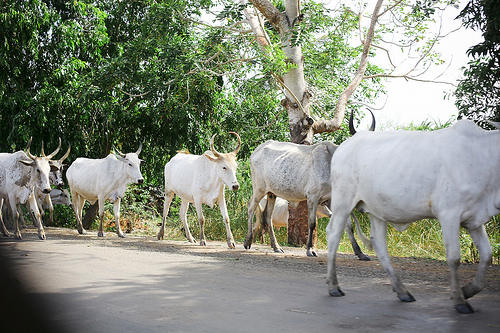<image>
Is the cow on the grass? No. The cow is not positioned on the grass. They may be near each other, but the cow is not supported by or resting on top of the grass. 